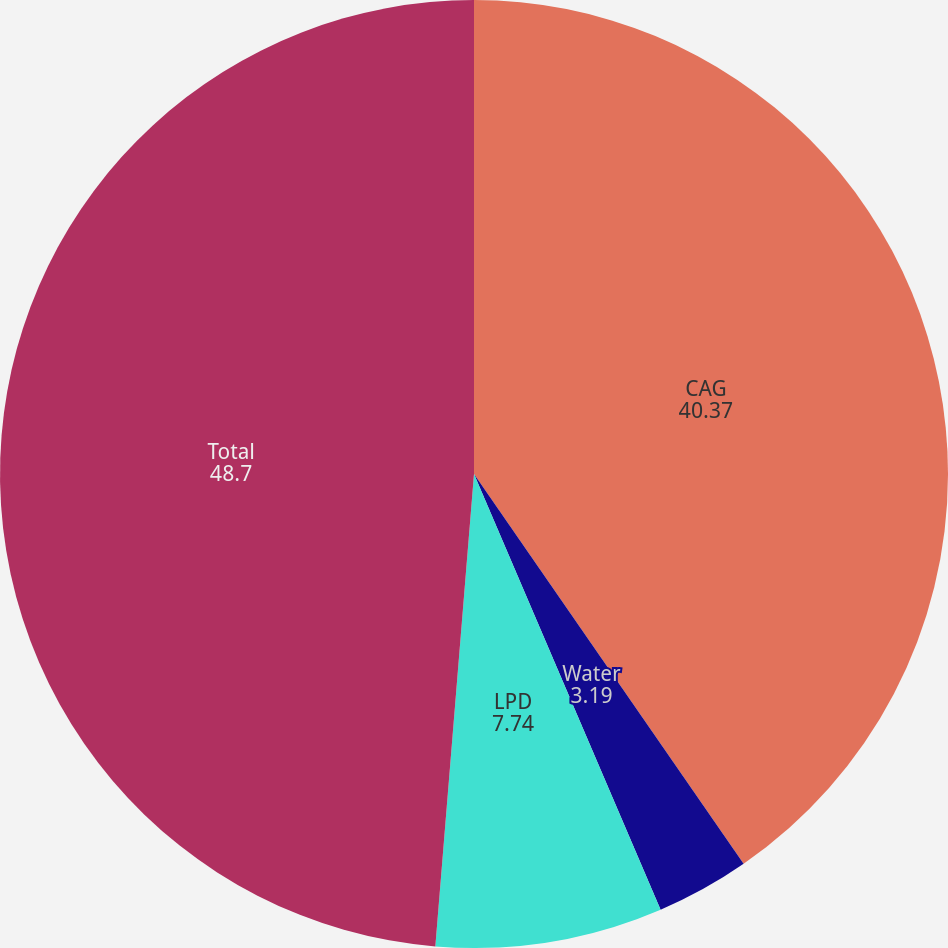<chart> <loc_0><loc_0><loc_500><loc_500><pie_chart><fcel>CAG<fcel>Water<fcel>LPD<fcel>Total<nl><fcel>40.37%<fcel>3.19%<fcel>7.74%<fcel>48.7%<nl></chart> 